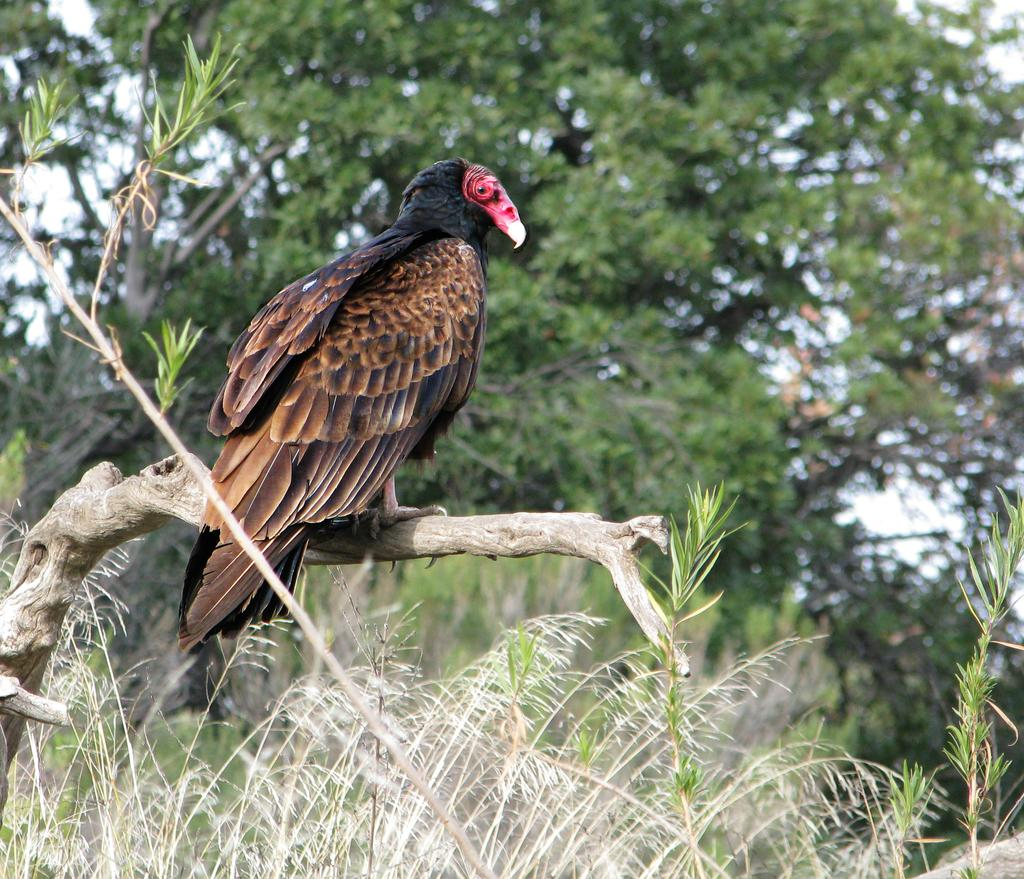What type of animal can be seen in the image? There is a bird in the image. Where is the bird located? The bird is standing on a branch of a tree. What else can be seen in the image besides the bird? There are other trees visible in the background of the image. What is the weight of the bird in the image? The weight of the bird cannot be determined from the image alone, as it depends on the species and individual bird. 